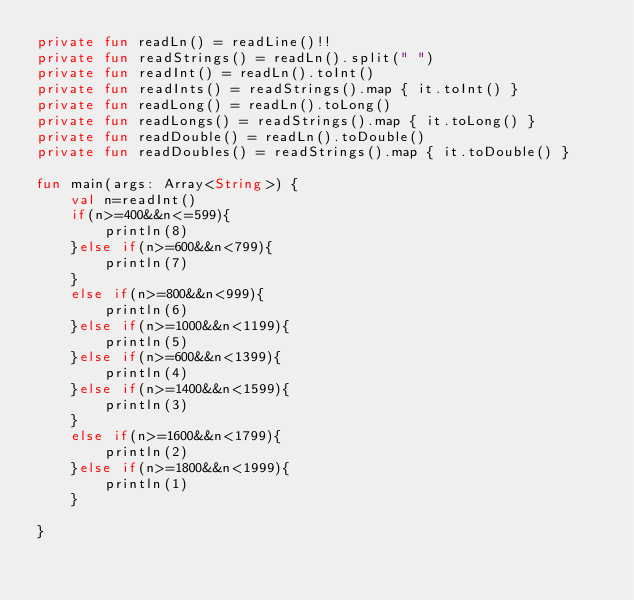Convert code to text. <code><loc_0><loc_0><loc_500><loc_500><_Kotlin_>private fun readLn() = readLine()!!
private fun readStrings() = readLn().split(" ")
private fun readInt() = readLn().toInt()
private fun readInts() = readStrings().map { it.toInt() }
private fun readLong() = readLn().toLong()
private fun readLongs() = readStrings().map { it.toLong() }
private fun readDouble() = readLn().toDouble()
private fun readDoubles() = readStrings().map { it.toDouble() }

fun main(args: Array<String>) {
    val n=readInt()
    if(n>=400&&n<=599){
        println(8)
    }else if(n>=600&&n<799){
        println(7)
    }
    else if(n>=800&&n<999){
        println(6)
    }else if(n>=1000&&n<1199){
        println(5)
    }else if(n>=600&&n<1399){
        println(4)
    }else if(n>=1400&&n<1599){
        println(3)
    }
    else if(n>=1600&&n<1799){
        println(2)
    }else if(n>=1800&&n<1999){
        println(1)
    }

}</code> 